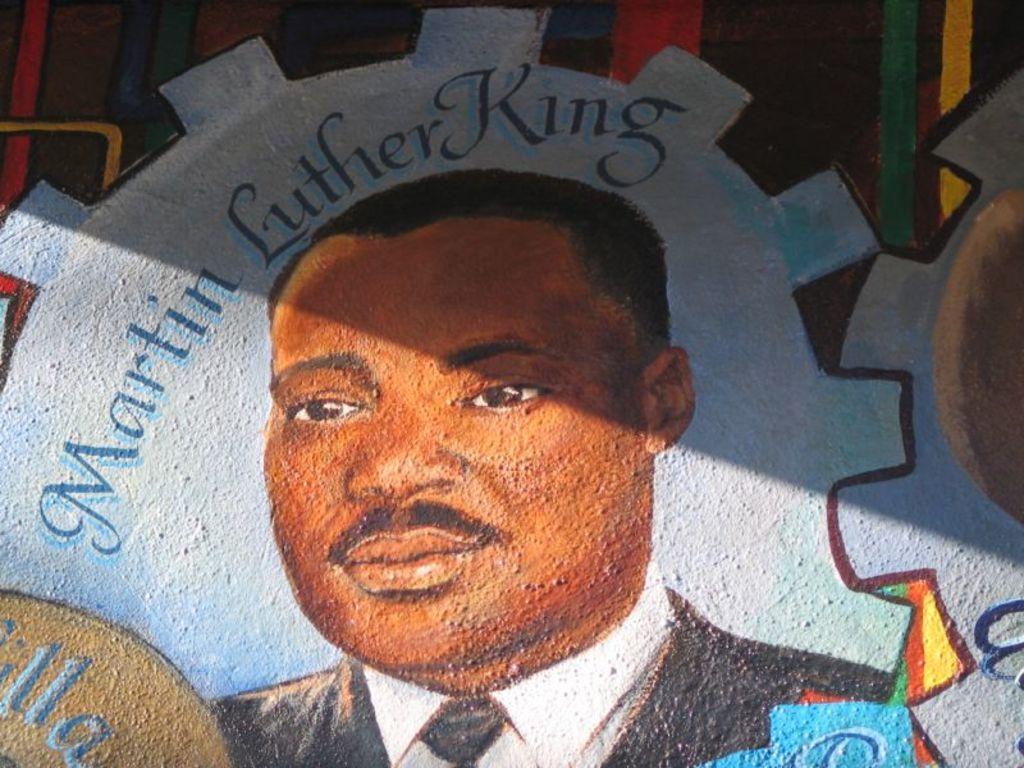How would you summarize this image in a sentence or two? In the center of the image there is a wall and we can see a painting of a martin luther king on it. 